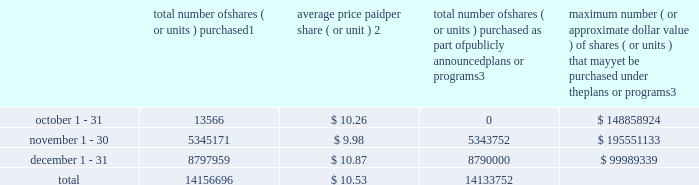Repurchase of equity securities the table provides information regarding our purchases of our equity securities during the period from october 1 , 2012 to december 31 , 2012 .
Total number of shares ( or units ) purchased 1 average price paid per share ( or unit ) 2 total number of shares ( or units ) purchased as part of publicly announced plans or programs 3 maximum number ( or approximate dollar value ) of shares ( or units ) that may yet be purchased under the plans or programs 3 .
1 includes shares of our common stock , par value $ 0.10 per share , withheld under the terms of grants under employee stock-based compensation plans to offset tax withholding obligations that occurred upon vesting and release of restricted shares ( the 201cwithheld shares 201d ) .
We repurchased 13566 withheld shares in october 2012 , 1419 withheld shares in november 2012 and 7959 withheld shares in december 2012 , for a total of 22944 withheld shares during the three-month period .
2 the average price per share for each of the months in the fiscal quarter and for the three-month period was calculated by dividing the sum of the applicable period of the aggregate value of the tax withholding obligations and the aggregate amount we paid for shares acquired under our stock repurchase program , described in note 5 to the consolidated financial statements , by the sum of the number of withheld shares and the number of shares acquired in our stock repurchase program .
3 on february 24 , 2012 , we announced in a press release that our board had approved a share repurchase program to repurchase from time to time up to $ 300.0 million of our common stock ( the 201c2012 share repurchase program 201d ) , in addition to amounts available on existing authorizations .
On november 20 , 2012 , we announced in a press release that our board had authorized an increase in our 2012 share repurchase program to $ 400.0 million of our common stock .
On february 22 , 2013 , we announced that our board had approved a new share repurchase program to repurchase from time to time up to $ 300.0 million of our common stock .
The new authorization is in addition to any amounts remaining available for repurchase under the 2012 share repurchase program .
There is no expiration date associated with the share repurchase programs. .
What percentage of total shares were purchased in october? 
Computations: ((13566 / 14156696) * 100)
Answer: 0.09583. 